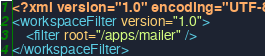Convert code to text. <code><loc_0><loc_0><loc_500><loc_500><_XML_><?xml version="1.0" encoding="UTF-8"?>
<workspaceFilter version="1.0">
	<filter root="/apps/mailer" />
</workspaceFilter>
</code> 